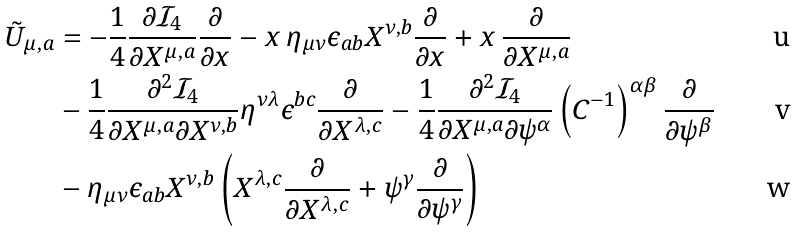Convert formula to latex. <formula><loc_0><loc_0><loc_500><loc_500>\tilde { U } _ { \mu , a } & = - \frac { 1 } { 4 } \frac { \partial \mathcal { I } _ { 4 } } { \partial X ^ { \mu , a } } \frac { \partial } { \partial x } - x \, \eta _ { \mu \nu } \epsilon _ { a b } X ^ { \nu , b } \frac { \partial } { \partial x } + x \, \frac { \partial } { \partial X ^ { \mu , a } } \\ & - \frac { 1 } { 4 } \frac { \partial ^ { 2 } \mathcal { I } _ { 4 } } { \partial X ^ { \mu , a } \partial X ^ { \nu , b } } \eta ^ { \nu \lambda } \epsilon ^ { b c } \frac { \partial } { \partial X ^ { \lambda , c } } - \frac { 1 } { 4 } \frac { \partial ^ { 2 } \mathcal { I } _ { 4 } } { \partial X ^ { \mu , a } \partial \psi ^ { \alpha } } \left ( C ^ { - 1 } \right ) ^ { \alpha \beta } \frac { \partial } { \partial \psi ^ { \beta } } \\ & - \eta _ { \mu \nu } \epsilon _ { a b } X ^ { \nu , b } \left ( X ^ { \lambda , c } \frac { \partial } { \partial X ^ { \lambda , c } } + \psi ^ { \gamma } \frac { \partial } { \partial \psi ^ { \gamma } } \right )</formula> 